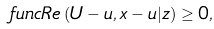<formula> <loc_0><loc_0><loc_500><loc_500>\ f u n c { R e } \left ( U - u , x - u | z \right ) \geq 0 ,</formula> 